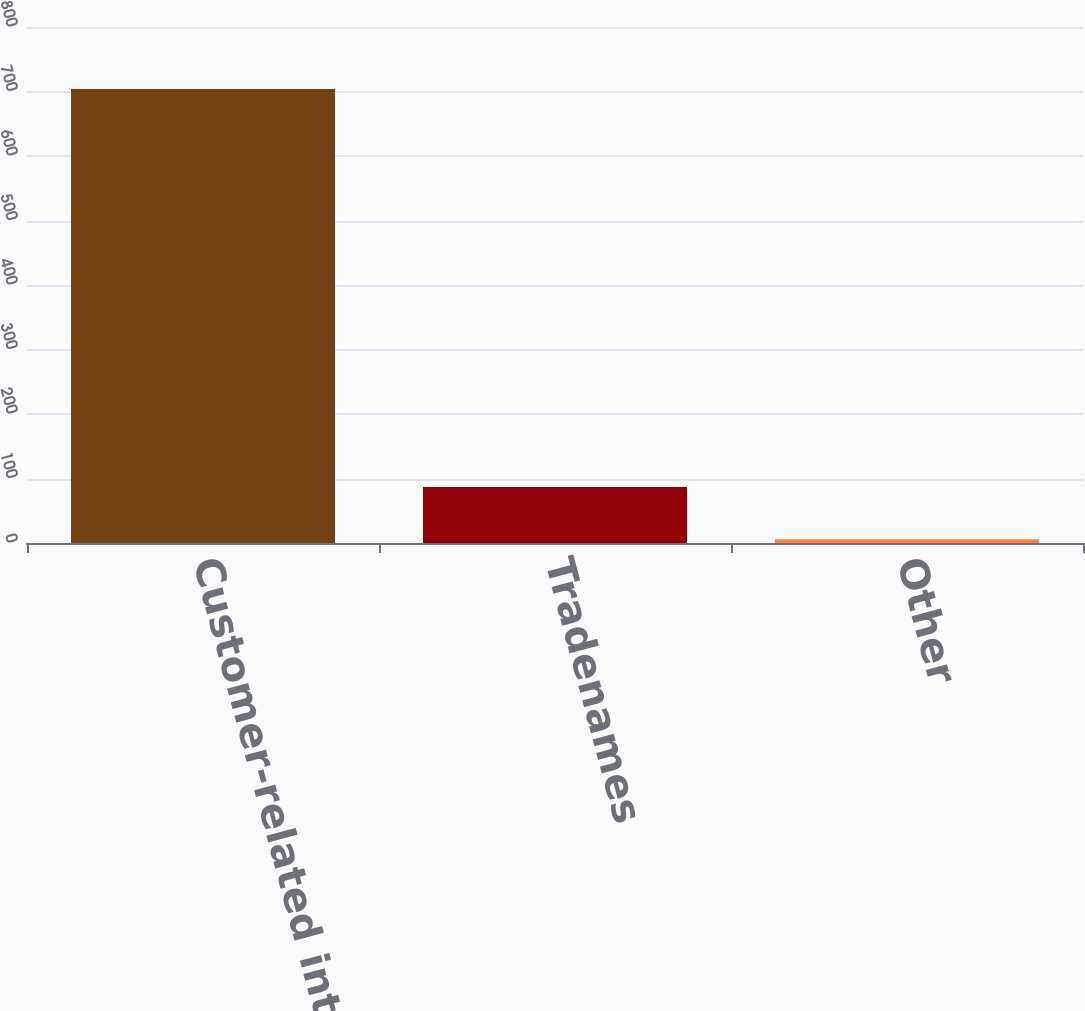Convert chart to OTSL. <chart><loc_0><loc_0><loc_500><loc_500><bar_chart><fcel>Customer-related intangibles<fcel>Tradenames<fcel>Other<nl><fcel>704<fcel>87<fcel>6<nl></chart> 